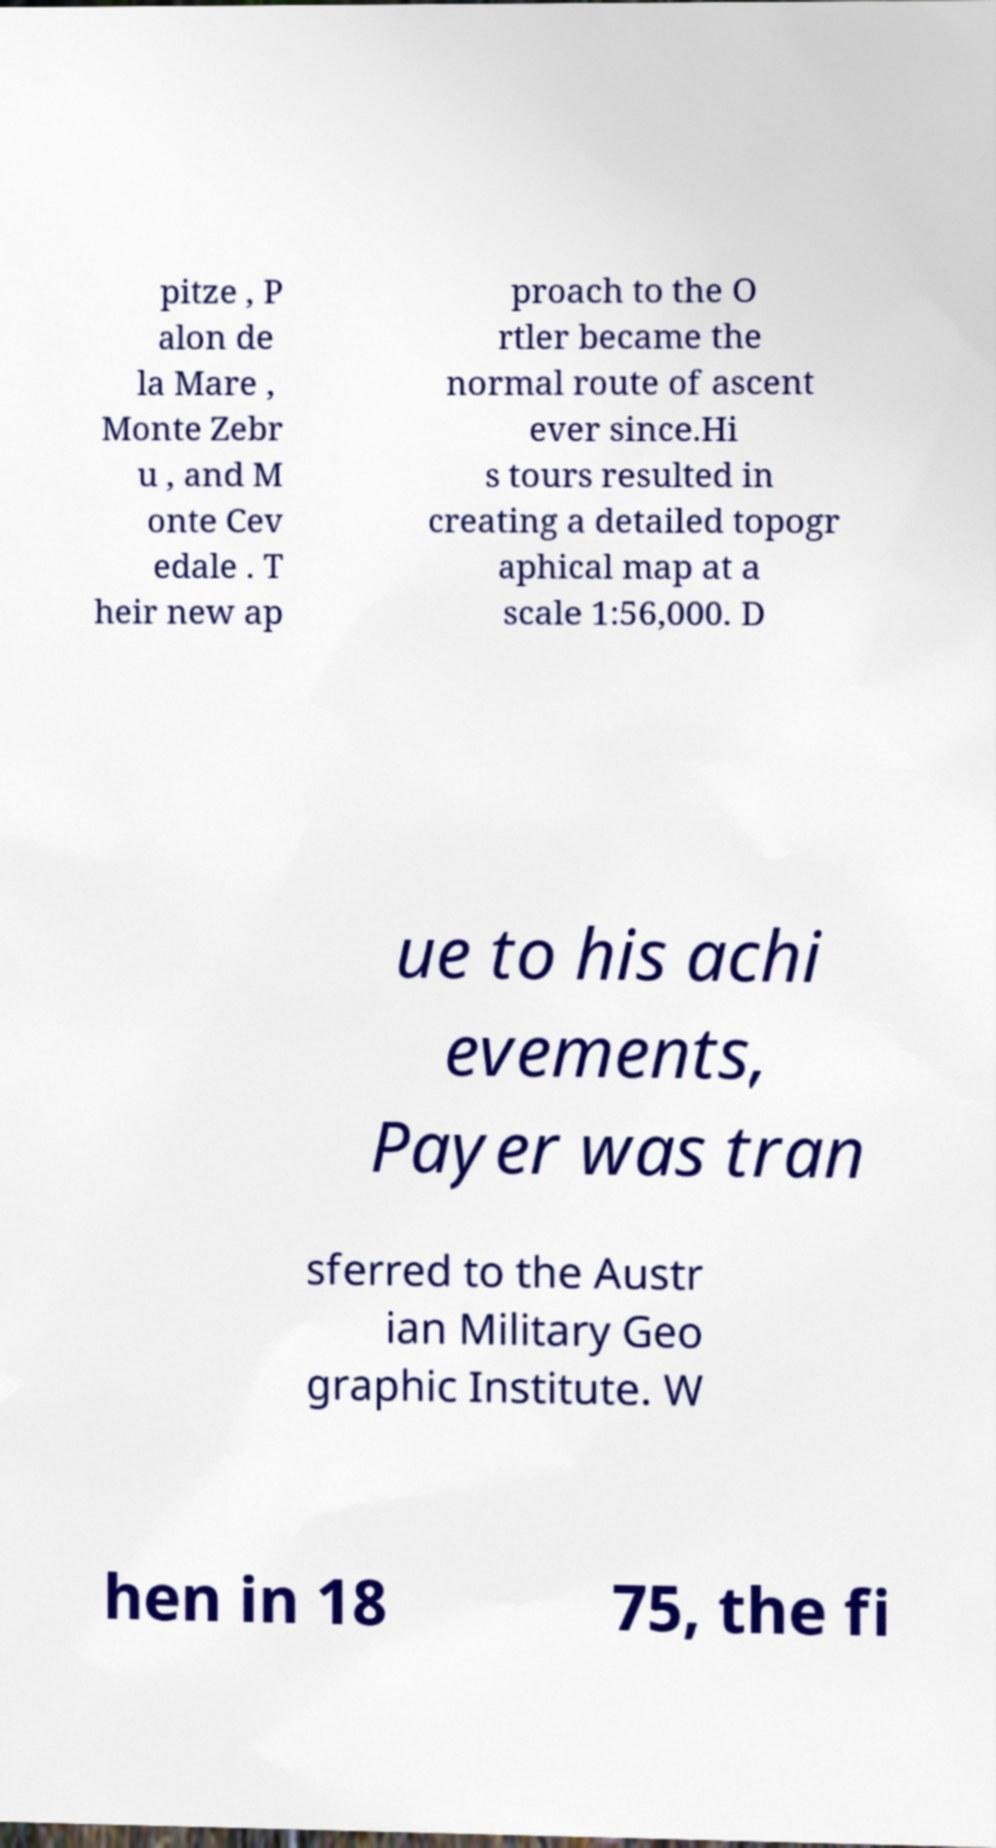For documentation purposes, I need the text within this image transcribed. Could you provide that? pitze , P alon de la Mare , Monte Zebr u , and M onte Cev edale . T heir new ap proach to the O rtler became the normal route of ascent ever since.Hi s tours resulted in creating a detailed topogr aphical map at a scale 1:56,000. D ue to his achi evements, Payer was tran sferred to the Austr ian Military Geo graphic Institute. W hen in 18 75, the fi 